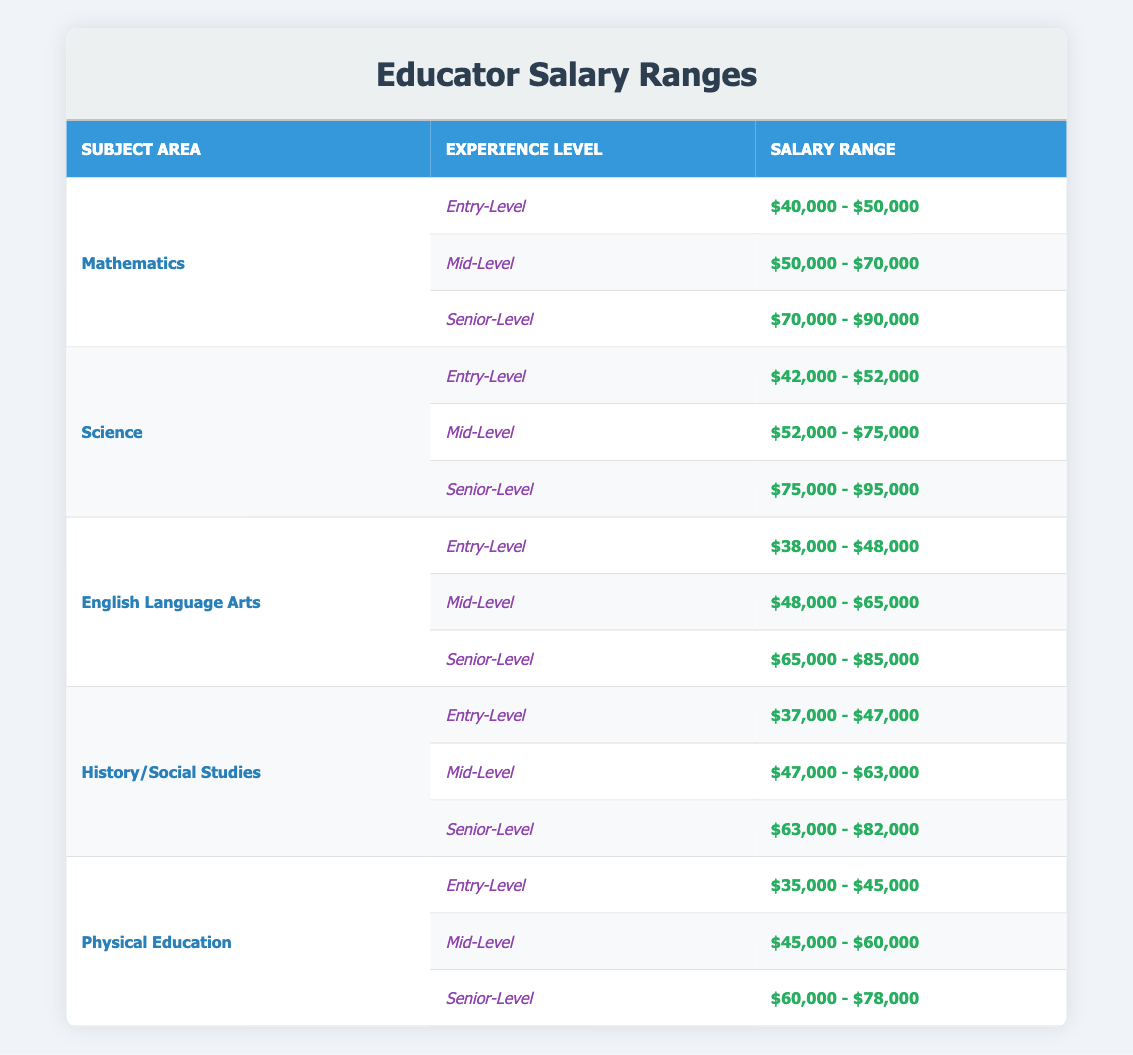What is the salary range for an Entry-Level Mathematics educator? The salary range for an Entry-Level Mathematics educator is listed directly in the table. It states "$40,000 - $50,000" as the range for this experience level.
Answer: $40,000 - $50,000 What is the salary range for a Senior-Level educator in Science? To find this, I look under the Science subject area for the Senior-Level experience category, which is "$75,000 - $95,000".
Answer: $75,000 - $95,000 Which subject area has the highest salary range for Mid-Level educators? I need to compare the salary ranges for Mid-Level educators across all subject areas. Mathematics has $50,000 - $70,000, Science has $52,000 - $75,000, English Language Arts has $48,000 - $65,000, History/Social Studies has $47,000 - $63,000, and Physical Education has $45,000 - $60,000. The highest is Science, which has an upper range of $75,000.
Answer: Science What is the difference in salary range between Entry-Level and Senior-Level educators in History/Social Studies? First, I find the salary range for Entry-Level in History/Social Studies which is "$37,000 - $47,000". The Senior-Level range is "$63,000 - $82,000". The difference in the lower bounds is $63,000 - $37,000 = $26,000 and in the upper bounds is $82,000 - $47,000 = $35,000. Thus, the difference varies based on upper and lower ranges.
Answer: Lower: $26,000; Upper: $35,000 Is it true that the Entry-Level salary for Physical Education is higher than that of English Language Arts? The Entry-Level salary for Physical Education is "$35,000 - $45,000" while for English Language Arts it is "$38,000 - $48,000". Since $35,000 is less than $38,000, the statement is false.
Answer: No What is the average salary range of Mid-Level educators across all subjects? I calculate the average salary ranges for all the Mid-Level educators. For Mid-Level: Mathematics is $60,000, Science is $63,500, English Language Arts is $56,500, History/Social Studies is $55,000, and Physical Education is $52,500. The total of the averages is $60,000 + $63,500 + $56,500 + $55,000 + $52,500 = $287,500. Dividing by 5 gives an average of $57,500.
Answer: $57,500 What is the salary range for a Mid-Level educator in Physical Education? The salary range for a Mid-Level educator in Physical Education is listed under that subject area in the table, which states it as "$45,000 - $60,000".
Answer: $45,000 - $60,000 Which subject area has the lowest Entry-Level salary range? I compare all the Entry-Level salary ranges: Mathematics ($40,000 - $50,000), Science ($42,000 - $52,000), English Language Arts ($38,000 - $48,000), History/Social Studies ($37,000 - $47,000), and Physical Education ($35,000 - $45,000). The lowest salary range for Entry-Level is Physical Education at $35,000.
Answer: Physical Education What is the upper limit of the Senior-Level salary range for English Language Arts? The upper limit of the Senior-Level salary range for English Language Arts is directly stated in the table as "$85,000".
Answer: $85,000 